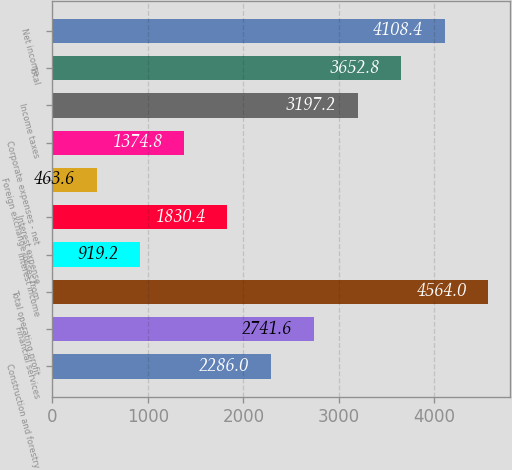Convert chart. <chart><loc_0><loc_0><loc_500><loc_500><bar_chart><fcel>Construction and forestry<fcel>Financial services<fcel>Total operating profit<fcel>Interest income<fcel>Interest expense<fcel>Foreign exchange losses from<fcel>Corporate expenses - net<fcel>Income taxes<fcel>Total<fcel>Net income<nl><fcel>2286<fcel>2741.6<fcel>4564<fcel>919.2<fcel>1830.4<fcel>463.6<fcel>1374.8<fcel>3197.2<fcel>3652.8<fcel>4108.4<nl></chart> 